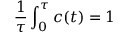Convert formula to latex. <formula><loc_0><loc_0><loc_500><loc_500>\frac { 1 } { \tau } \int _ { 0 } ^ { \tau } c ( t ) = 1</formula> 